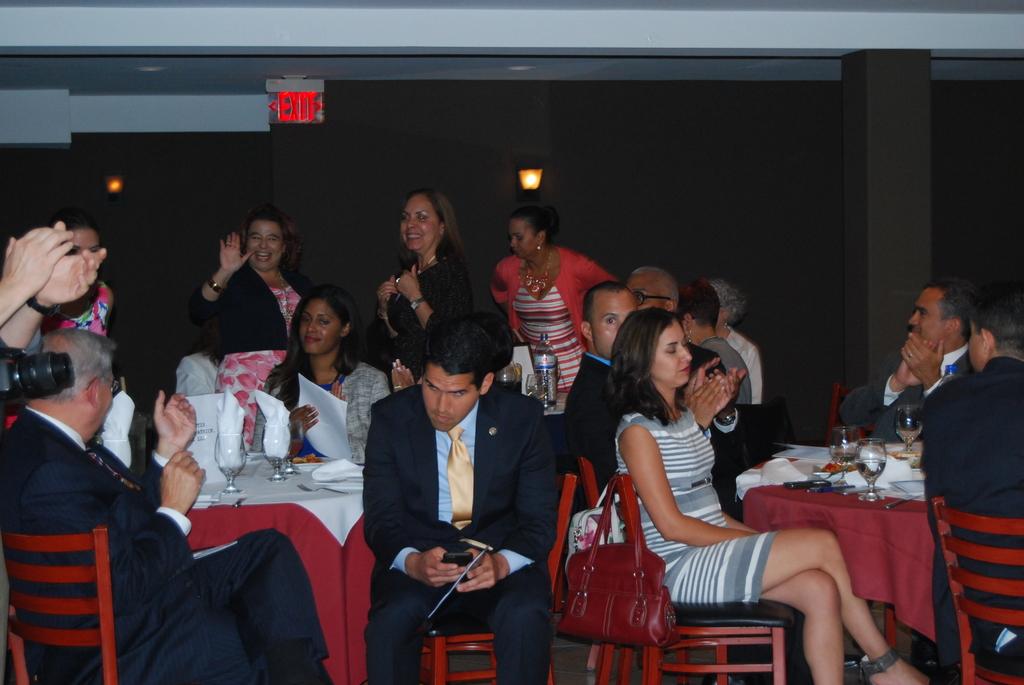What does sign say on the back wall?
Ensure brevity in your answer.  Exit. 